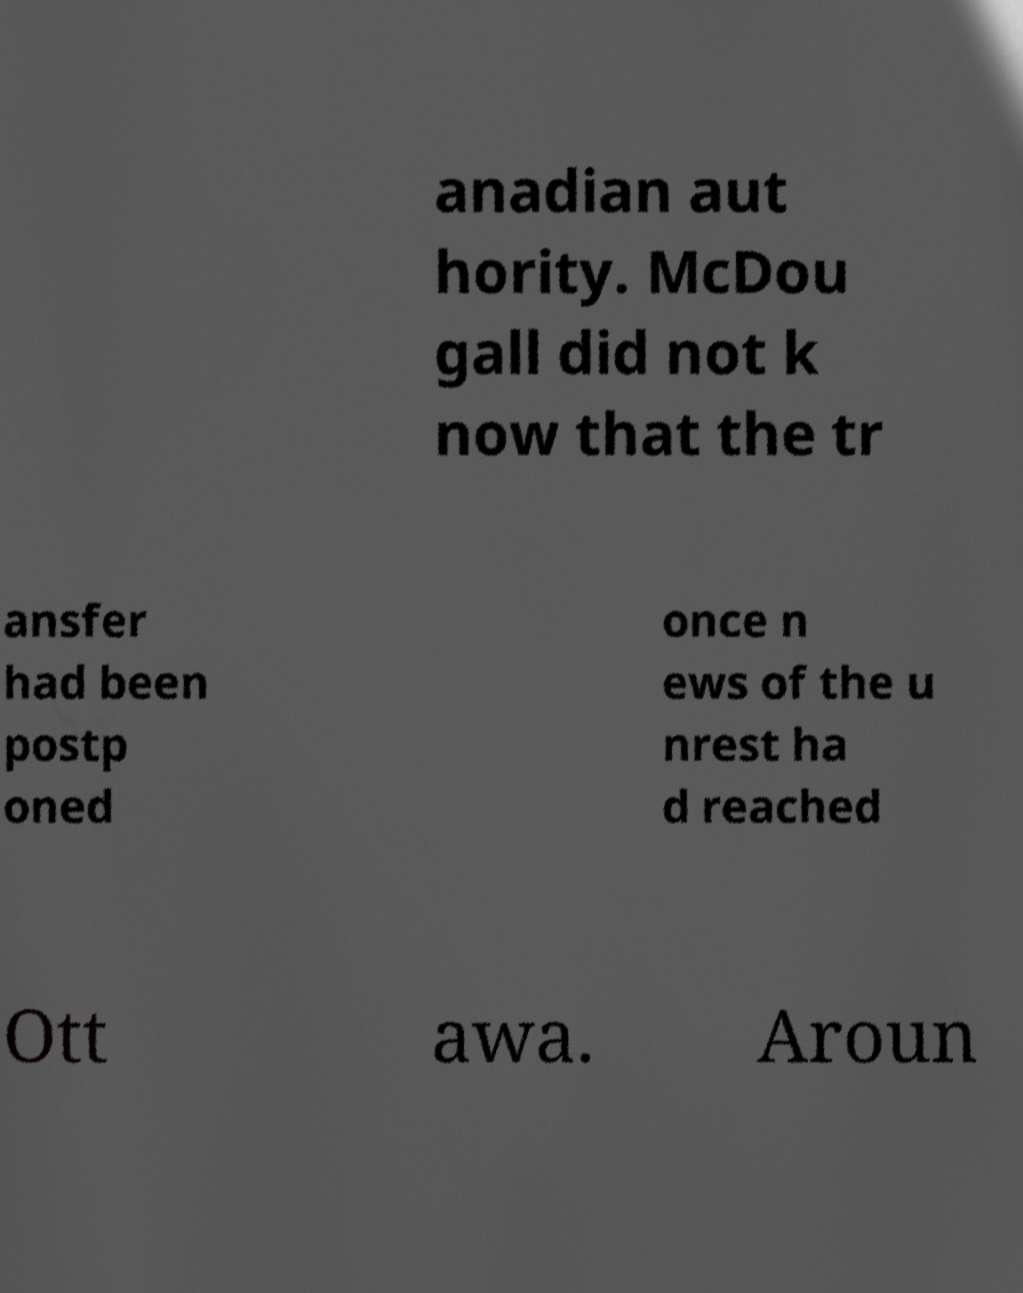I need the written content from this picture converted into text. Can you do that? anadian aut hority. McDou gall did not k now that the tr ansfer had been postp oned once n ews of the u nrest ha d reached Ott awa. Aroun 